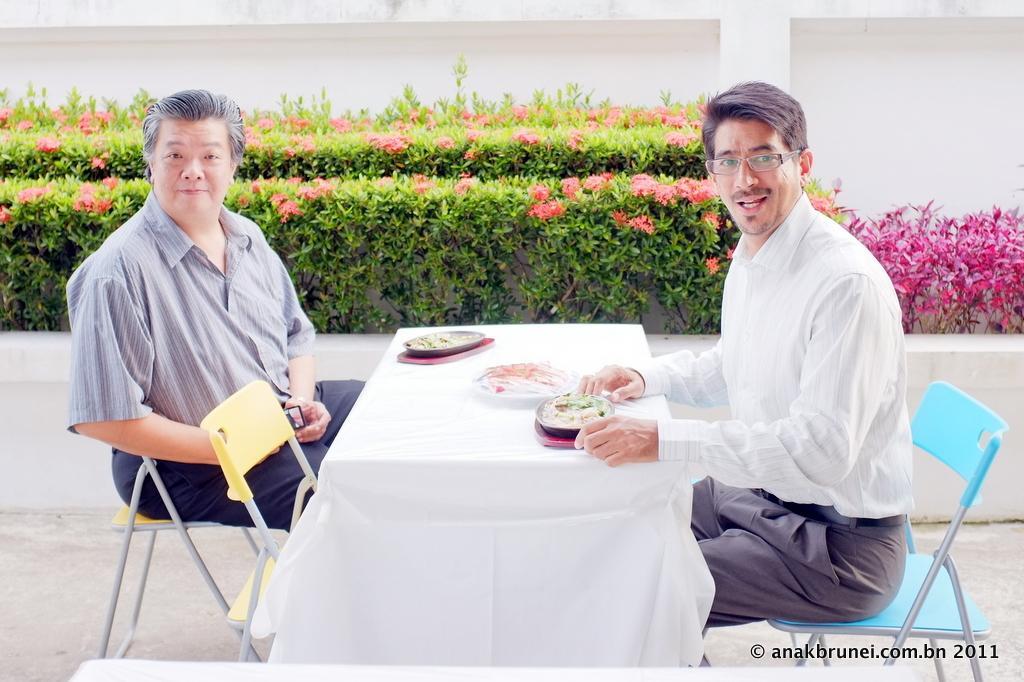In one or two sentences, can you explain what this image depicts? In this image we can see this two persons are sitting on the chairs near the table. We can see plates with food on the table. In the background of the image we can see shrubs and a wall. 